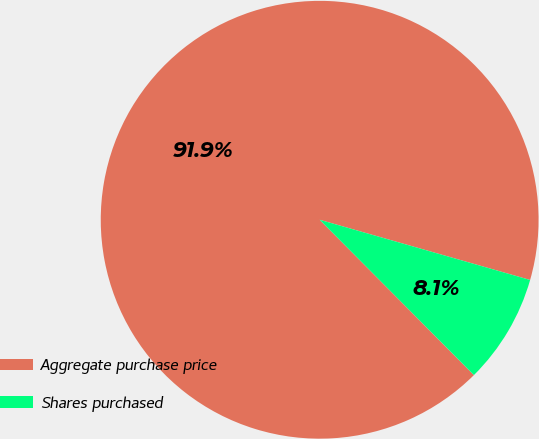Convert chart. <chart><loc_0><loc_0><loc_500><loc_500><pie_chart><fcel>Aggregate purchase price<fcel>Shares purchased<nl><fcel>91.88%<fcel>8.12%<nl></chart> 